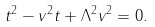<formula> <loc_0><loc_0><loc_500><loc_500>t ^ { 2 } - v ^ { 2 } t + \Lambda ^ { 2 } v ^ { 2 } = 0 .</formula> 